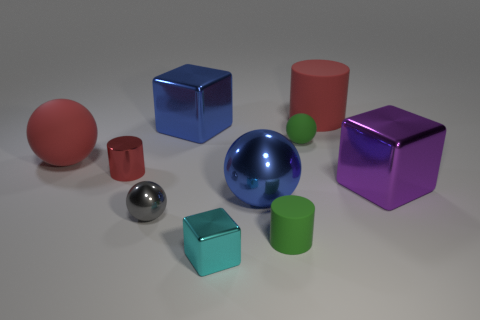What is the material of the big purple block?
Provide a succinct answer. Metal. What shape is the red shiny thing that is the same size as the cyan metallic thing?
Keep it short and to the point. Cylinder. Are there an equal number of big metallic blocks behind the small cube and rubber cylinders behind the tiny gray ball?
Provide a succinct answer. No. What size is the red cylinder right of the large ball that is to the right of the red metal cylinder?
Your answer should be very brief. Large. Are there any other rubber things of the same size as the cyan object?
Your answer should be compact. Yes. The other large cube that is made of the same material as the big blue block is what color?
Your answer should be compact. Purple. Is the number of tiny cyan metallic objects less than the number of tiny metal objects?
Your answer should be very brief. Yes. The sphere that is both behind the red shiny cylinder and on the left side of the tiny green rubber cylinder is made of what material?
Make the answer very short. Rubber. Is there a cube that is behind the rubber ball in front of the tiny green matte ball?
Provide a succinct answer. Yes. What number of other metallic cylinders have the same color as the large cylinder?
Keep it short and to the point. 1. 